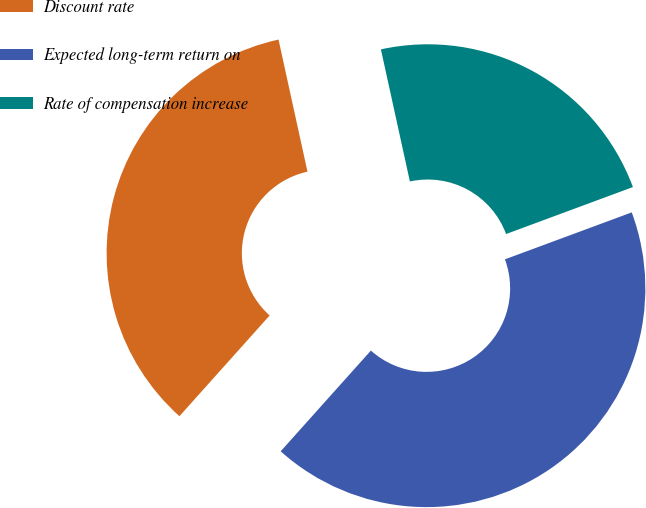Convert chart to OTSL. <chart><loc_0><loc_0><loc_500><loc_500><pie_chart><fcel>Discount rate<fcel>Expected long-term return on<fcel>Rate of compensation increase<nl><fcel>34.94%<fcel>42.27%<fcel>22.79%<nl></chart> 